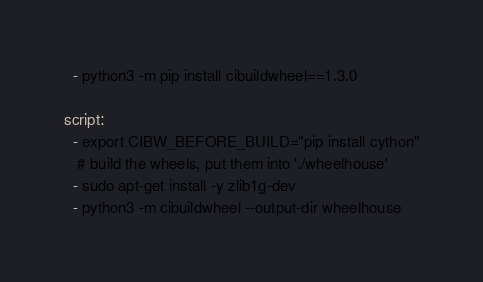<code> <loc_0><loc_0><loc_500><loc_500><_YAML_>  - python3 -m pip install cibuildwheel==1.3.0

script:
  - export CIBW_BEFORE_BUILD="pip install cython"
   # build the wheels, put them into './wheelhouse'
  - sudo apt-get install -y zlib1g-dev
  - python3 -m cibuildwheel --output-dir wheelhouse

</code> 